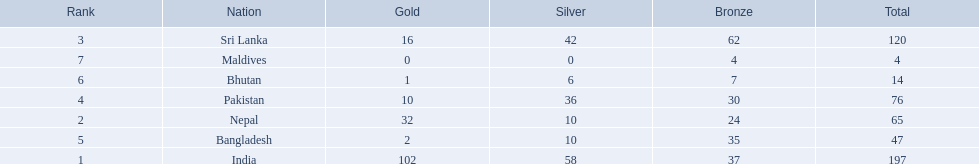Which countries won medals? India, Nepal, Sri Lanka, Pakistan, Bangladesh, Bhutan, Maldives. Which won the most? India. Would you be able to parse every entry in this table? {'header': ['Rank', 'Nation', 'Gold', 'Silver', 'Bronze', 'Total'], 'rows': [['3', 'Sri Lanka', '16', '42', '62', '120'], ['7', 'Maldives', '0', '0', '4', '4'], ['6', 'Bhutan', '1', '6', '7', '14'], ['4', 'Pakistan', '10', '36', '30', '76'], ['2', 'Nepal', '32', '10', '24', '65'], ['5', 'Bangladesh', '2', '10', '35', '47'], ['1', 'India', '102', '58', '37', '197']]} Which won the fewest? Maldives. 